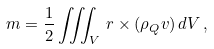Convert formula to latex. <formula><loc_0><loc_0><loc_500><loc_500>m = { \frac { 1 } { 2 } } \iiint _ { V } \, r \times ( \rho _ { Q } v ) \, { d } V \, ,</formula> 